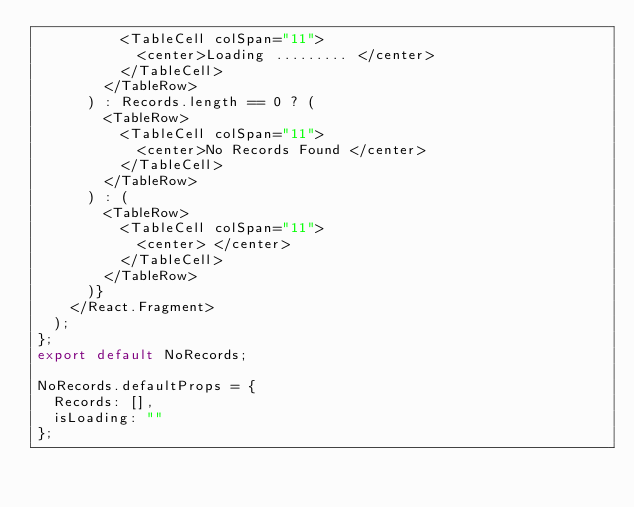Convert code to text. <code><loc_0><loc_0><loc_500><loc_500><_JavaScript_>          <TableCell colSpan="11">
            <center>Loading ......... </center>
          </TableCell>
        </TableRow>
      ) : Records.length == 0 ? (
        <TableRow>
          <TableCell colSpan="11">
            <center>No Records Found </center>
          </TableCell>
        </TableRow>
      ) : (
        <TableRow>
          <TableCell colSpan="11">
            <center> </center>
          </TableCell>
        </TableRow>
      )}
    </React.Fragment>
  );
};
export default NoRecords;

NoRecords.defaultProps = {
  Records: [],
  isLoading: ""
};
</code> 